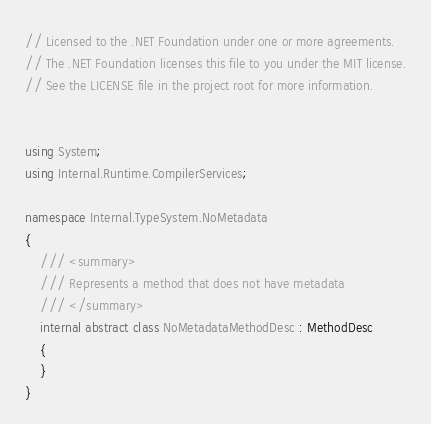Convert code to text. <code><loc_0><loc_0><loc_500><loc_500><_C#_>// Licensed to the .NET Foundation under one or more agreements.
// The .NET Foundation licenses this file to you under the MIT license.
// See the LICENSE file in the project root for more information.


using System;
using Internal.Runtime.CompilerServices;

namespace Internal.TypeSystem.NoMetadata
{
    /// <summary>
    /// Represents a method that does not have metadata
    /// </summary>
    internal abstract class NoMetadataMethodDesc : MethodDesc
    {
    }
}</code> 